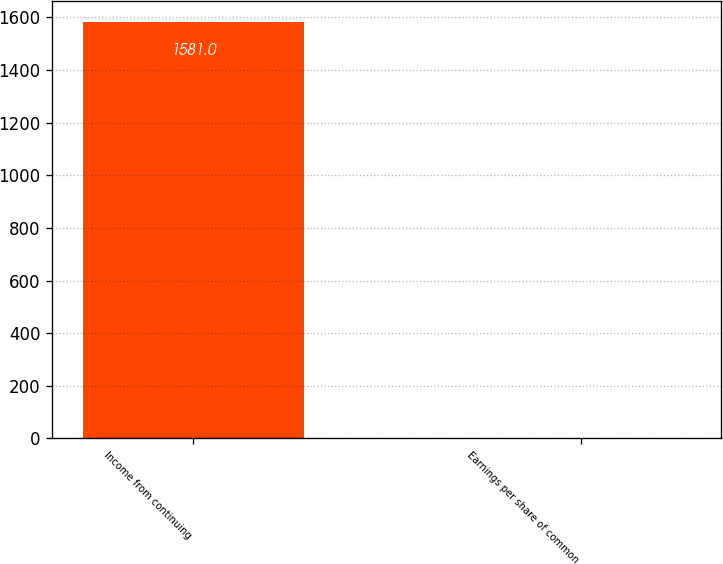<chart> <loc_0><loc_0><loc_500><loc_500><bar_chart><fcel>Income from continuing<fcel>Earnings per share of common<nl><fcel>1581<fcel>1.86<nl></chart> 